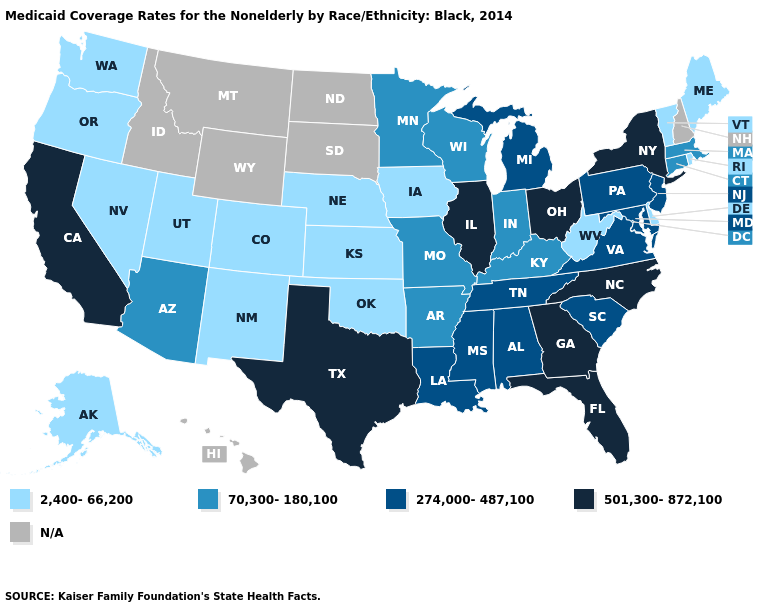What is the value of Oregon?
Concise answer only. 2,400-66,200. Which states hav the highest value in the MidWest?
Keep it brief. Illinois, Ohio. What is the value of Montana?
Concise answer only. N/A. What is the lowest value in the South?
Give a very brief answer. 2,400-66,200. What is the value of Tennessee?
Concise answer only. 274,000-487,100. Which states have the lowest value in the USA?
Answer briefly. Alaska, Colorado, Delaware, Iowa, Kansas, Maine, Nebraska, Nevada, New Mexico, Oklahoma, Oregon, Rhode Island, Utah, Vermont, Washington, West Virginia. Which states have the lowest value in the West?
Quick response, please. Alaska, Colorado, Nevada, New Mexico, Oregon, Utah, Washington. What is the value of West Virginia?
Concise answer only. 2,400-66,200. Among the states that border North Carolina , does South Carolina have the highest value?
Give a very brief answer. No. Name the states that have a value in the range 501,300-872,100?
Write a very short answer. California, Florida, Georgia, Illinois, New York, North Carolina, Ohio, Texas. Name the states that have a value in the range N/A?
Answer briefly. Hawaii, Idaho, Montana, New Hampshire, North Dakota, South Dakota, Wyoming. Does the map have missing data?
Short answer required. Yes. Name the states that have a value in the range 2,400-66,200?
Keep it brief. Alaska, Colorado, Delaware, Iowa, Kansas, Maine, Nebraska, Nevada, New Mexico, Oklahoma, Oregon, Rhode Island, Utah, Vermont, Washington, West Virginia. Name the states that have a value in the range 2,400-66,200?
Keep it brief. Alaska, Colorado, Delaware, Iowa, Kansas, Maine, Nebraska, Nevada, New Mexico, Oklahoma, Oregon, Rhode Island, Utah, Vermont, Washington, West Virginia. What is the lowest value in states that border Illinois?
Concise answer only. 2,400-66,200. 